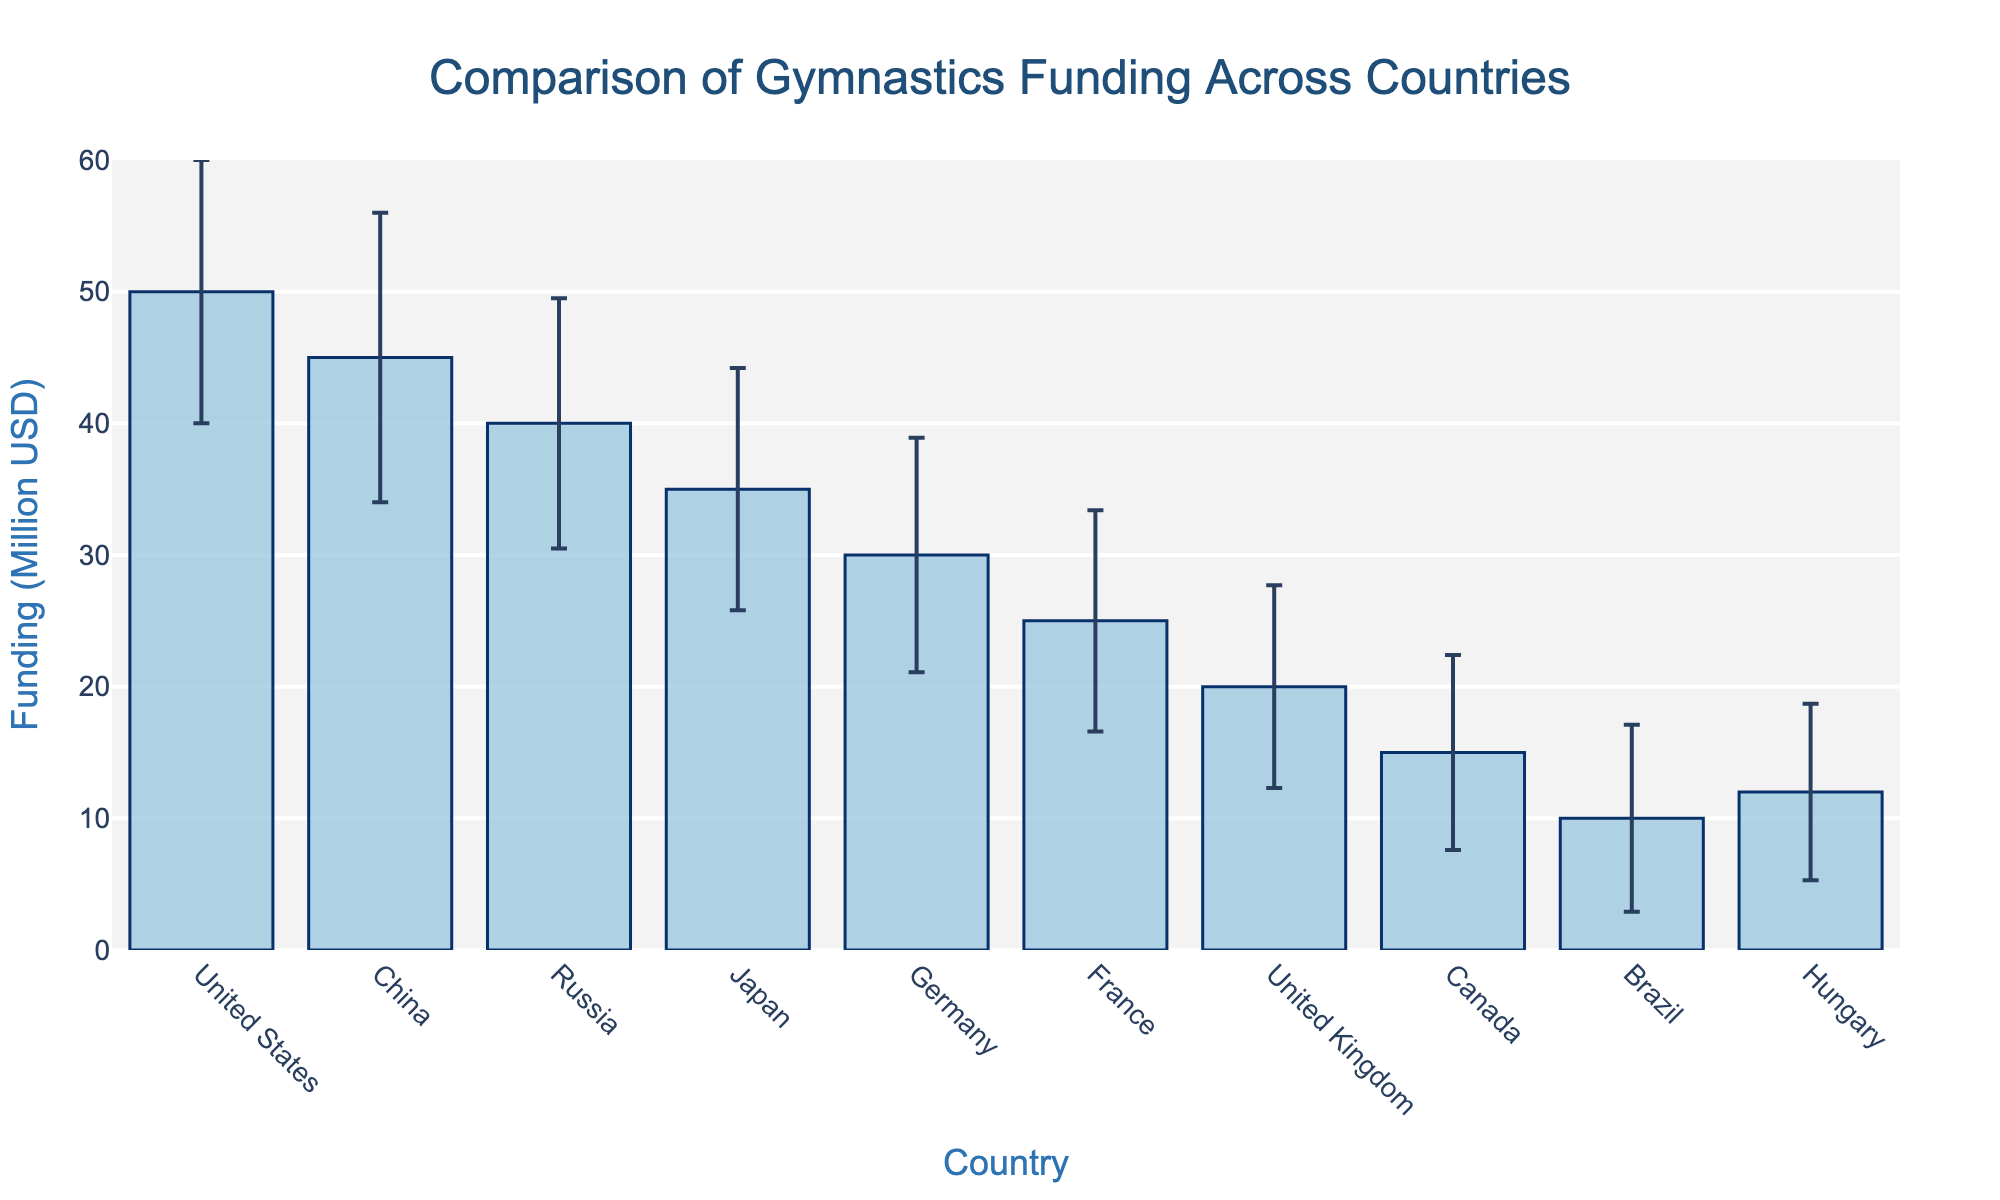What is the title of the figure? The title of the figure is displayed at the top in large, bold text. It provides an overview of what the figure is about.
Answer: Comparison of Gymnastics Funding Across Countries Which country has the highest funding for gymnastics programs? The country with the highest bar in the figure represents the one with the most funding.
Answer: United States What is the color of the bars representing funding for gymnastics? The bars in the figure are filled with a solid color, which helps to distinguish the funding data visually.
Answer: Light blue How much funding does Hungary receive for gymnastics programs? Locate the bar labeled "Hungary" on the horizontal axis and read its corresponding value on the vertical axis.
Answer: 12 million USD What is the range of values shown on the y-axis? The y-axis indicates the scale of funding values, so observe the range starting from the lowest to the highest value displayed.
Answer: 0 to 60 million USD How do the funding amounts of Germany and France compare? Identify the bars for Germany and France, and compare their heights based on the scale on the y-axis.
Answer: Germany's funding is 30 million USD and France's funding is 25 million USD Which country has the smallest standard error in its funding? The standard error bars for each country give a visual indication of variance, with the smallest bars representing the smallest standard errors.
Answer: Hungary What is the difference in funding between China and the United Kingdom? Calculate the difference by subtracting the funding amount of the United Kingdom from that of China.
Answer: 45 million USD - 20 million USD = 25 million USD What proportion of the highest funding does Hungary receive? To find the proportion, divide Hungary's funding by the highest funding value and multiply by 100 to get a percentage.
Answer: (12 million USD / 50 million USD) * 100 = 24% Which countries have a funding variance higher than 100? Look at the variance values in the dataset and list countries where the variance is greater than 100.
Answer: United States, China What is the total funding for all countries combined? Sum the funding amounts for all the countries listed in the dataset.
Answer: 50 + 45 + 40 + 35 + 30 + 25 + 20 + 15 + 10 + 12 = 282 million USD 